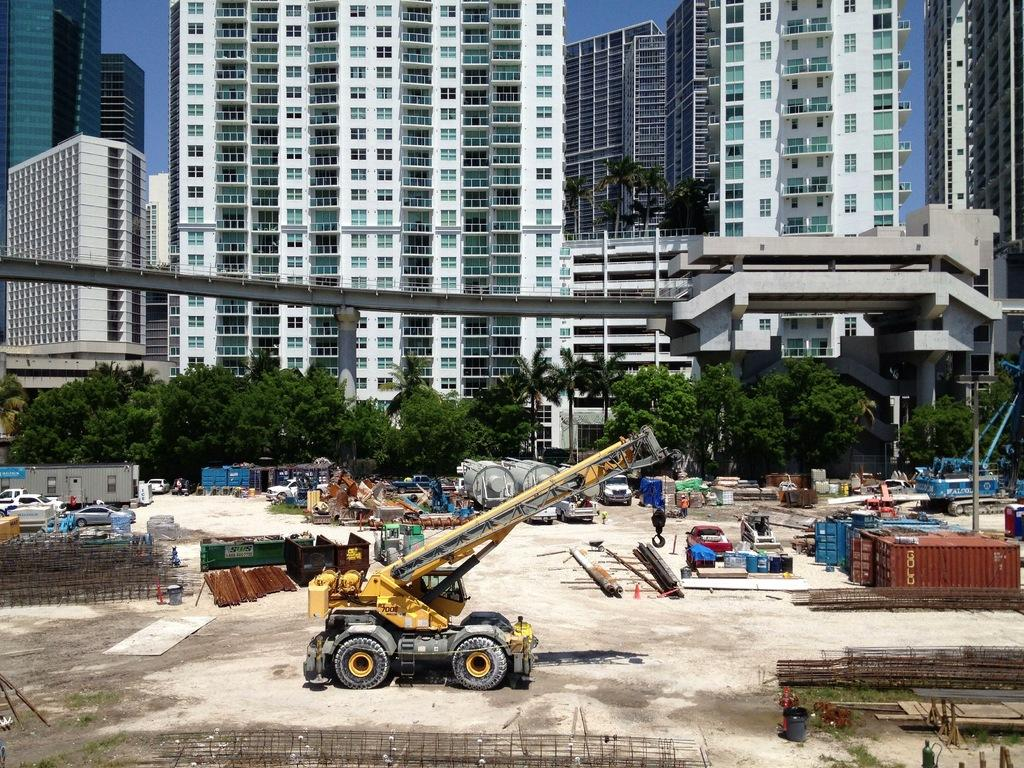What type of machinery can be seen in the image? There is a crane in the image. What other objects are present in the image? Metal rods, containers, and vehicles are visible in the image. What type of vegetation is present in the image? Trees are present in the image. What structures can be seen in the background of the image? There are buildings and a bridge visible in the background of the image. What part of the natural environment is visible in the image? The sky is visible in the background of the image. What type of soap is being used to clean the kite in the image? There is no soap or kite present in the image. How many bottles of water are visible in the image? There are no bottles visible in the image. 